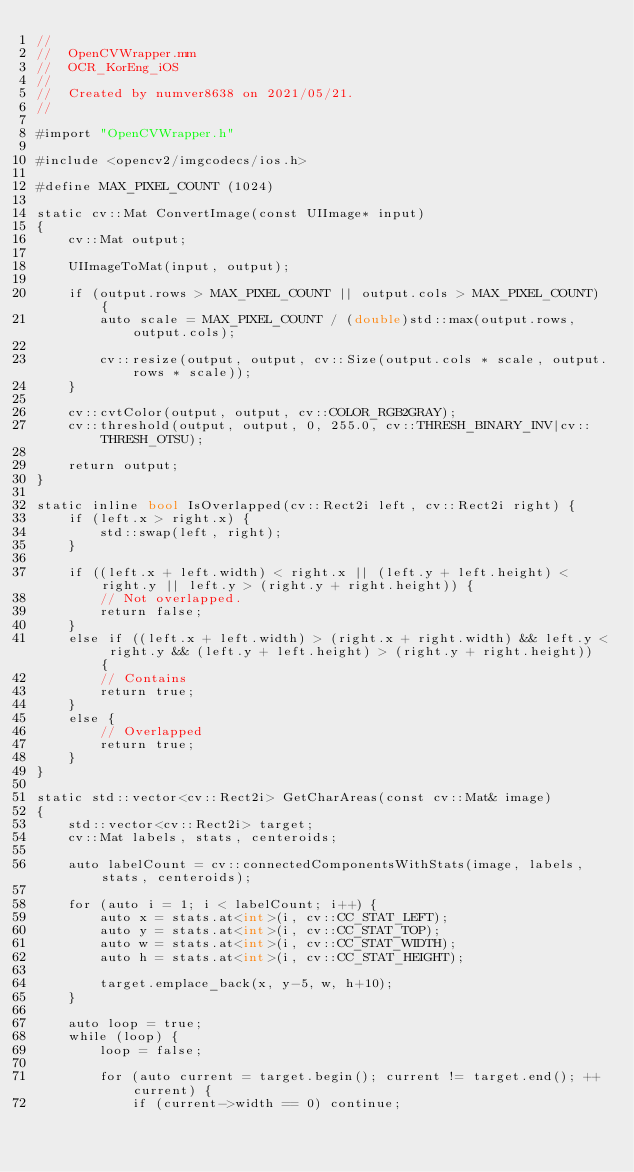Convert code to text. <code><loc_0><loc_0><loc_500><loc_500><_ObjectiveC_>//
//  OpenCVWrapper.mm
//  OCR_KorEng_iOS
//
//  Created by numver8638 on 2021/05/21.
//

#import "OpenCVWrapper.h"

#include <opencv2/imgcodecs/ios.h>

#define MAX_PIXEL_COUNT (1024)

static cv::Mat ConvertImage(const UIImage* input)
{
    cv::Mat output;
    
    UIImageToMat(input, output);
    
    if (output.rows > MAX_PIXEL_COUNT || output.cols > MAX_PIXEL_COUNT) {
        auto scale = MAX_PIXEL_COUNT / (double)std::max(output.rows, output.cols);
        
        cv::resize(output, output, cv::Size(output.cols * scale, output.rows * scale));
    }
    
    cv::cvtColor(output, output, cv::COLOR_RGB2GRAY);
    cv::threshold(output, output, 0, 255.0, cv::THRESH_BINARY_INV|cv::THRESH_OTSU);
    
    return output;
}

static inline bool IsOverlapped(cv::Rect2i left, cv::Rect2i right) {
    if (left.x > right.x) {
        std::swap(left, right);
    }
    
    if ((left.x + left.width) < right.x || (left.y + left.height) < right.y || left.y > (right.y + right.height)) {
        // Not overlapped.
        return false;
    }
    else if ((left.x + left.width) > (right.x + right.width) && left.y < right.y && (left.y + left.height) > (right.y + right.height)) {
        // Contains
        return true;
    }
    else {
        // Overlapped
        return true;
    }
}

static std::vector<cv::Rect2i> GetCharAreas(const cv::Mat& image)
{
    std::vector<cv::Rect2i> target;
    cv::Mat labels, stats, centeroids;
    
    auto labelCount = cv::connectedComponentsWithStats(image, labels, stats, centeroids);
    
    for (auto i = 1; i < labelCount; i++) {
        auto x = stats.at<int>(i, cv::CC_STAT_LEFT);
        auto y = stats.at<int>(i, cv::CC_STAT_TOP);
        auto w = stats.at<int>(i, cv::CC_STAT_WIDTH);
        auto h = stats.at<int>(i, cv::CC_STAT_HEIGHT);
        
        target.emplace_back(x, y-5, w, h+10);
    }
    
    auto loop = true;
    while (loop) {
        loop = false;
        
        for (auto current = target.begin(); current != target.end(); ++current) {
            if (current->width == 0) continue;
            </code> 